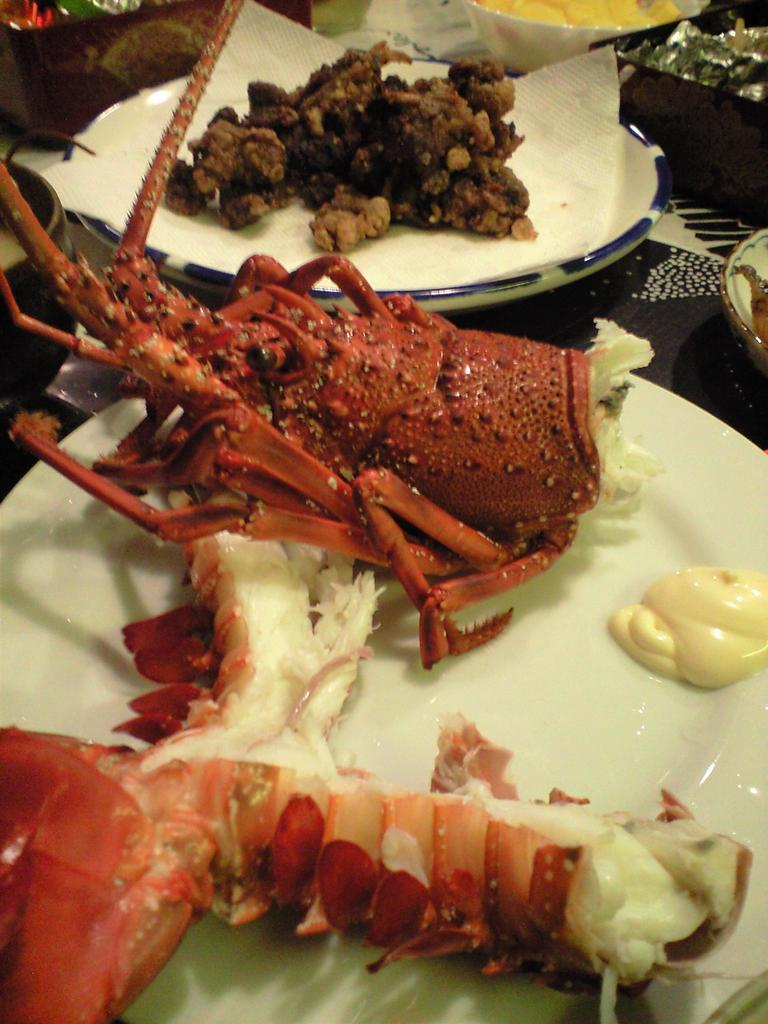What is the main subject in the center of the image? There is a lobster in the center of the image. What objects are present for serving or eating food? There are plates, bowls, and napkins in the image. What else can be seen in the image besides the lobster and serving items? There is food and a box on the table in the image. What type of glass is used to serve the lobster in the image? There is no glass present in the image; it features a lobster, plates, bowls, napkins, food, and a box on the table. Can you hear the lobster's ear in the image? There is no ear present in the image, as lobsters do not have ears. 